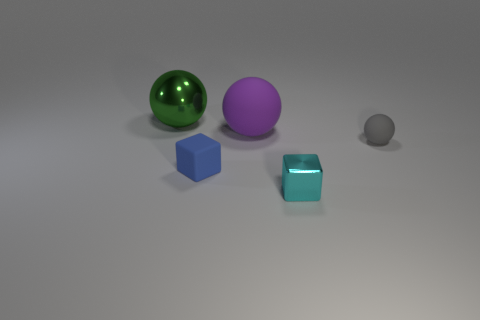What material is the sphere on the right side of the small thing in front of the small blue thing made of?
Your response must be concise. Rubber. Are there an equal number of green metallic spheres right of the cyan metal cube and small cyan cubes behind the gray matte object?
Provide a short and direct response. Yes. Do the tiny cyan object and the tiny gray rubber object have the same shape?
Provide a succinct answer. No. There is a tiny object that is on the right side of the tiny blue thing and in front of the small gray rubber object; what material is it?
Your answer should be compact. Metal. What number of other rubber things have the same shape as the tiny cyan thing?
Your answer should be compact. 1. There is a gray sphere that is in front of the shiny thing that is behind the tiny object behind the blue thing; what size is it?
Ensure brevity in your answer.  Small. Are there more big rubber spheres behind the large purple ball than small purple rubber things?
Offer a very short reply. No. Are any small yellow balls visible?
Provide a succinct answer. No. How many green metallic objects are the same size as the purple thing?
Make the answer very short. 1. Are there more purple things that are behind the large purple rubber ball than green metallic balls behind the cyan shiny cube?
Offer a very short reply. No. 